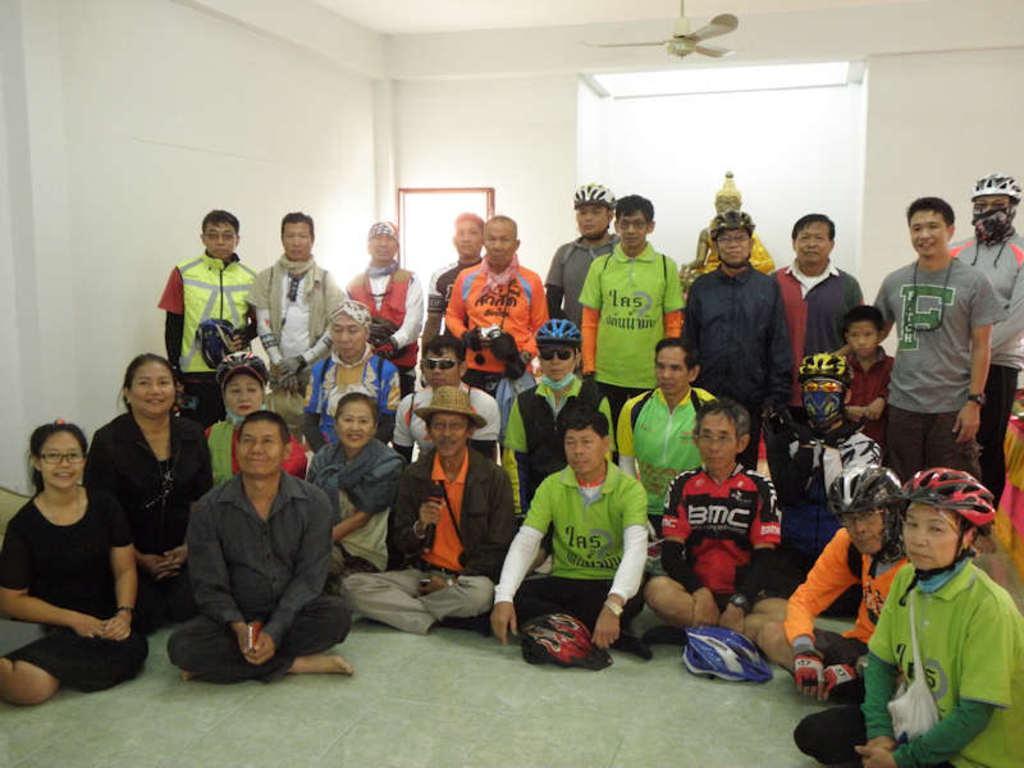How would you summarize this image in a sentence or two? This is the picture of a room. In this image there are group of people sitting and there are group of people standing and there is a statue behind the people. At the top there is a fan and there is a light. At the back it looks like a door. At the bottom there is a floor. 